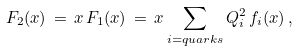Convert formula to latex. <formula><loc_0><loc_0><loc_500><loc_500>F _ { 2 } ( x ) \, = \, x \, F _ { 1 } ( x ) \, = \, x \sum _ { i = q u a r k s } Q _ { i } ^ { 2 } \, f _ { i } ( x ) \, ,</formula> 